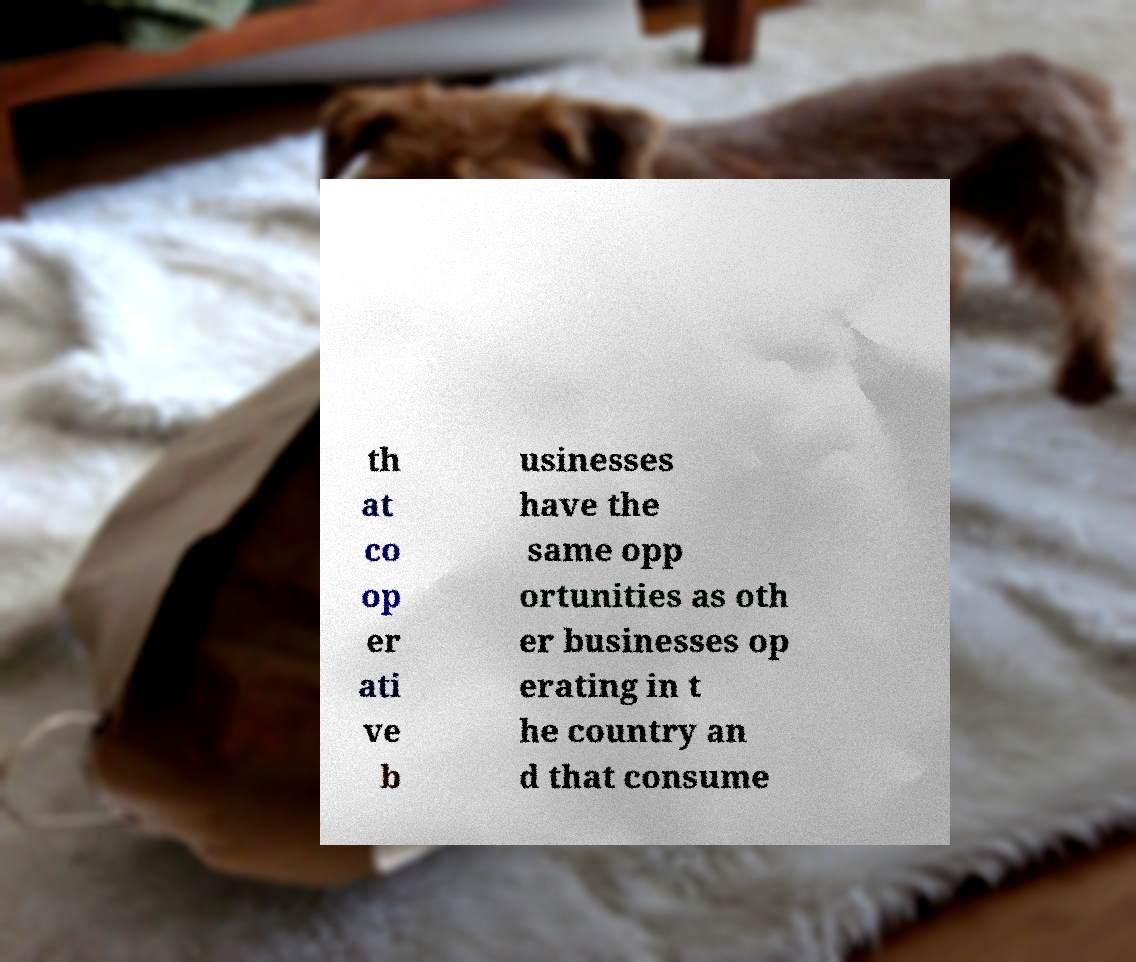For documentation purposes, I need the text within this image transcribed. Could you provide that? th at co op er ati ve b usinesses have the same opp ortunities as oth er businesses op erating in t he country an d that consume 